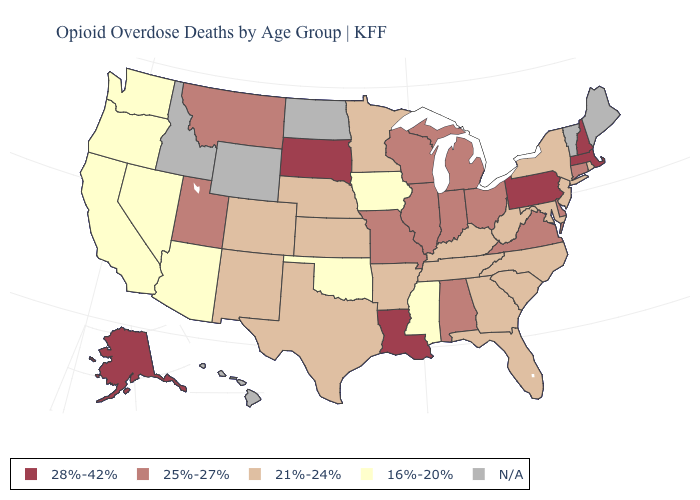Among the states that border Arizona , does California have the lowest value?
Be succinct. Yes. What is the value of Maine?
Quick response, please. N/A. Does Alaska have the highest value in the West?
Write a very short answer. Yes. What is the value of South Carolina?
Quick response, please. 21%-24%. Name the states that have a value in the range 16%-20%?
Short answer required. Arizona, California, Iowa, Mississippi, Nevada, Oklahoma, Oregon, Washington. Name the states that have a value in the range 25%-27%?
Answer briefly. Alabama, Connecticut, Delaware, Illinois, Indiana, Michigan, Missouri, Montana, Ohio, Utah, Virginia, Wisconsin. Which states have the lowest value in the Northeast?
Answer briefly. New Jersey, New York, Rhode Island. Name the states that have a value in the range 21%-24%?
Short answer required. Arkansas, Colorado, Florida, Georgia, Kansas, Kentucky, Maryland, Minnesota, Nebraska, New Jersey, New Mexico, New York, North Carolina, Rhode Island, South Carolina, Tennessee, Texas, West Virginia. What is the value of Pennsylvania?
Short answer required. 28%-42%. What is the value of Connecticut?
Write a very short answer. 25%-27%. What is the value of California?
Answer briefly. 16%-20%. Does Rhode Island have the highest value in the Northeast?
Give a very brief answer. No. What is the highest value in the USA?
Give a very brief answer. 28%-42%. What is the value of Michigan?
Concise answer only. 25%-27%. What is the highest value in states that border Colorado?
Give a very brief answer. 25%-27%. 